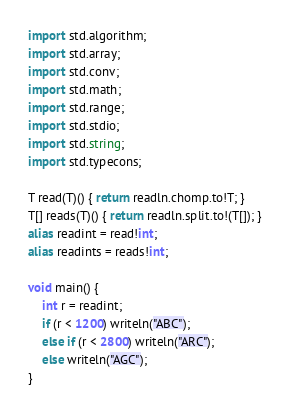<code> <loc_0><loc_0><loc_500><loc_500><_D_>import std.algorithm;
import std.array;
import std.conv;
import std.math;
import std.range;
import std.stdio;
import std.string;
import std.typecons;

T read(T)() { return readln.chomp.to!T; }
T[] reads(T)() { return readln.split.to!(T[]); }
alias readint = read!int;
alias readints = reads!int;

void main() {
    int r = readint;
    if (r < 1200) writeln("ABC");
    else if (r < 2800) writeln("ARC");
    else writeln("AGC");
}</code> 